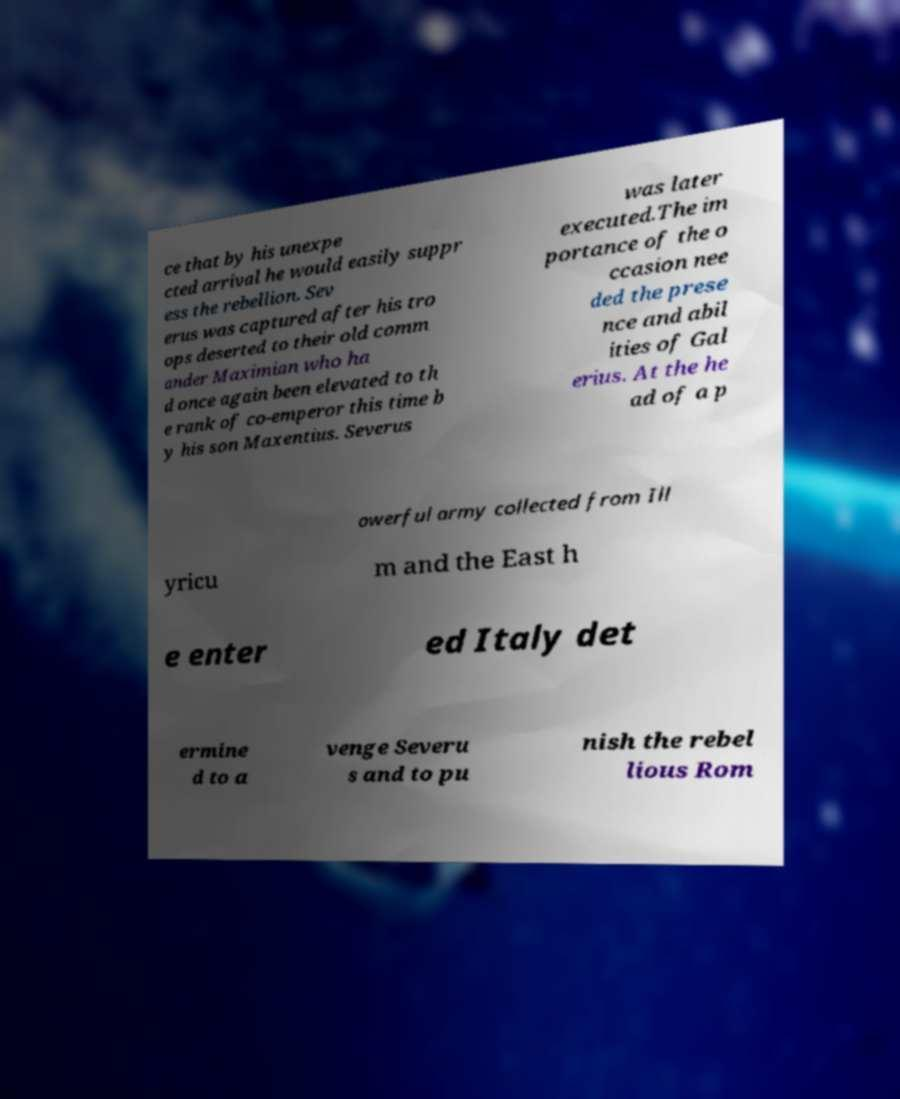For documentation purposes, I need the text within this image transcribed. Could you provide that? ce that by his unexpe cted arrival he would easily suppr ess the rebellion. Sev erus was captured after his tro ops deserted to their old comm ander Maximian who ha d once again been elevated to th e rank of co-emperor this time b y his son Maxentius. Severus was later executed.The im portance of the o ccasion nee ded the prese nce and abil ities of Gal erius. At the he ad of a p owerful army collected from Ill yricu m and the East h e enter ed Italy det ermine d to a venge Severu s and to pu nish the rebel lious Rom 